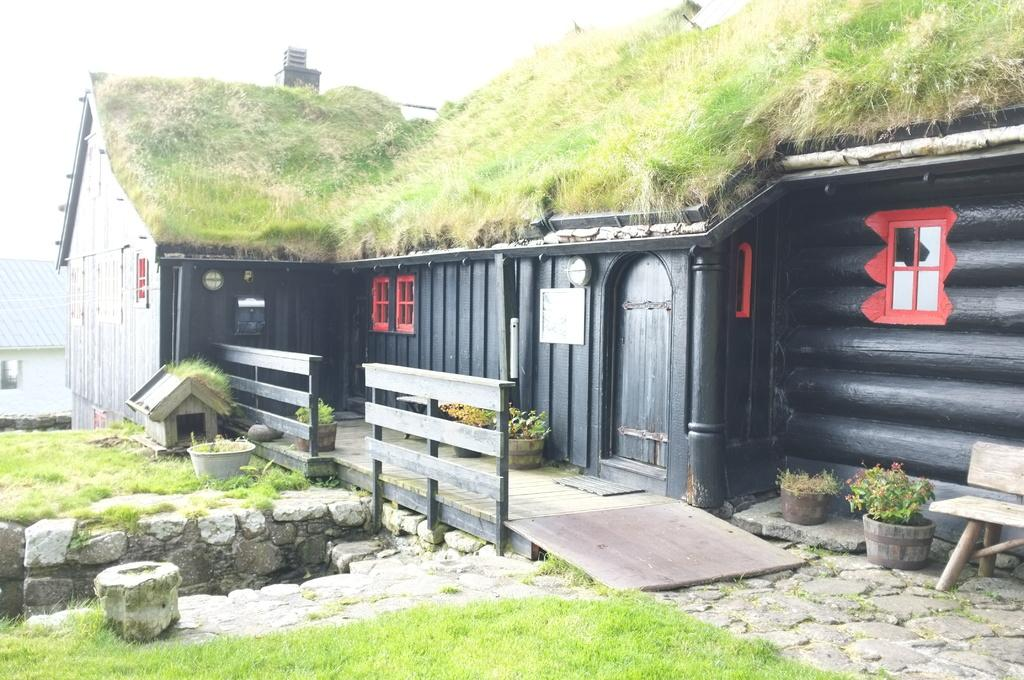What type of structures can be seen in the image? There are houses in the image. What type of vegetation is present in the image? Grass is present in the image. What type of natural features can be seen in the image? Rocks are visible in the image. What type of architectural elements can be seen in the image? Railings are in the image. What type of container for plants is present in the image? A planter is present in the image. What type of seating is available in the image? A bench is in the image. What part of the natural environment is visible in the image? The sky is visible in the image. What type of land cover is present in the image? The land is covered with grass. Can you tell me how many tubs are visible in the image? There are no tubs present in the image. What type of grass is growing on the bench in the image? There is no grass growing on the bench in the image; it is a seating area. 